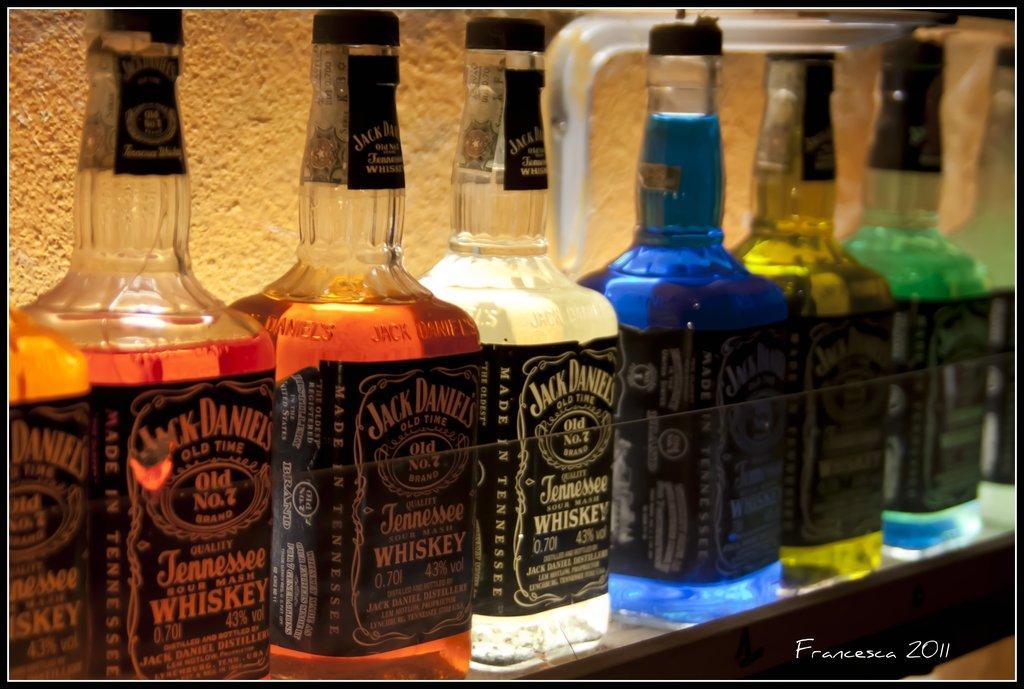In one or two sentences, can you explain what this image depicts? In the image we can see there are wine bottles which are kept in a row in the shelf. 